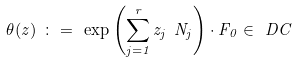Convert formula to latex. <formula><loc_0><loc_0><loc_500><loc_500>\theta ( z ) \ \colon = \ \exp \left ( \sum _ { j = 1 } ^ { r } z _ { j } \ N _ { j } \right ) \cdot F _ { 0 } \in \ D C</formula> 